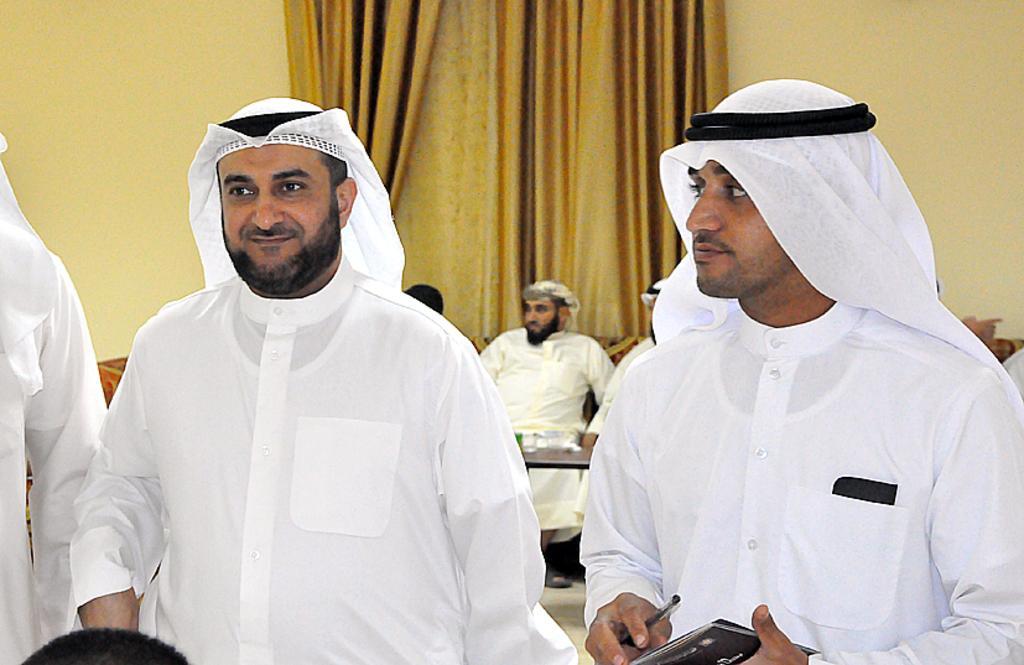Could you give a brief overview of what you see in this image? In this image there are three people wearing thobe, a person on the right side of the image is holding a book and a pen and behind him there are people sitting, there are curtains in the background. 